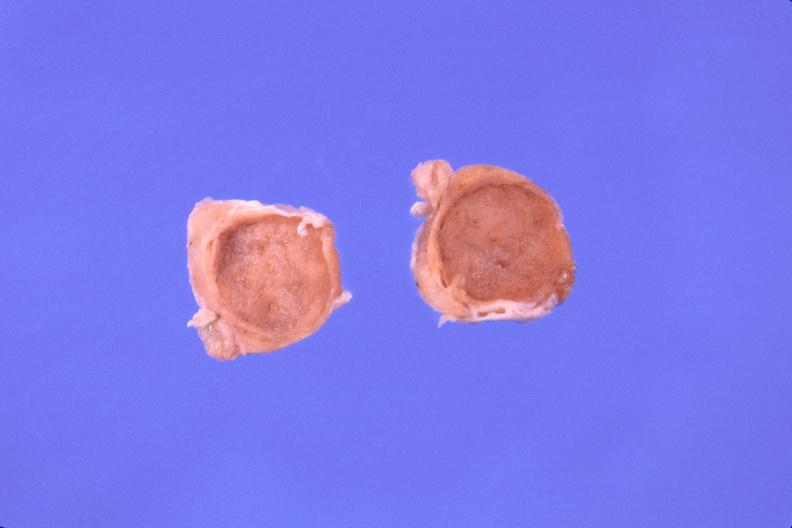s endocrine present?
Answer the question using a single word or phrase. Yes 